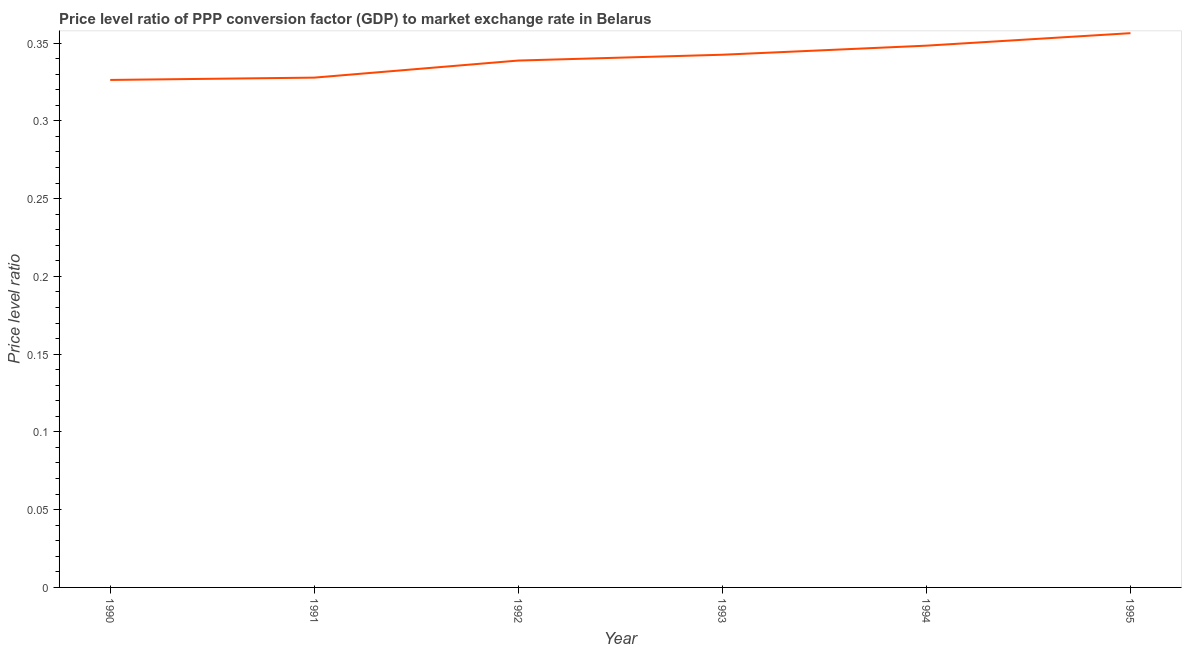What is the price level ratio in 1993?
Keep it short and to the point. 0.34. Across all years, what is the maximum price level ratio?
Your answer should be compact. 0.36. Across all years, what is the minimum price level ratio?
Your answer should be compact. 0.33. What is the sum of the price level ratio?
Give a very brief answer. 2.04. What is the difference between the price level ratio in 1992 and 1995?
Provide a short and direct response. -0.02. What is the average price level ratio per year?
Ensure brevity in your answer.  0.34. What is the median price level ratio?
Provide a short and direct response. 0.34. In how many years, is the price level ratio greater than 0.05 ?
Make the answer very short. 6. What is the ratio of the price level ratio in 1990 to that in 1992?
Provide a succinct answer. 0.96. What is the difference between the highest and the second highest price level ratio?
Keep it short and to the point. 0.01. What is the difference between the highest and the lowest price level ratio?
Offer a very short reply. 0.03. In how many years, is the price level ratio greater than the average price level ratio taken over all years?
Offer a very short reply. 3. Does the price level ratio monotonically increase over the years?
Give a very brief answer. Yes. What is the difference between two consecutive major ticks on the Y-axis?
Give a very brief answer. 0.05. What is the title of the graph?
Give a very brief answer. Price level ratio of PPP conversion factor (GDP) to market exchange rate in Belarus. What is the label or title of the X-axis?
Offer a terse response. Year. What is the label or title of the Y-axis?
Offer a terse response. Price level ratio. What is the Price level ratio in 1990?
Keep it short and to the point. 0.33. What is the Price level ratio of 1991?
Your answer should be very brief. 0.33. What is the Price level ratio of 1992?
Provide a short and direct response. 0.34. What is the Price level ratio of 1993?
Provide a succinct answer. 0.34. What is the Price level ratio of 1994?
Make the answer very short. 0.35. What is the Price level ratio of 1995?
Give a very brief answer. 0.36. What is the difference between the Price level ratio in 1990 and 1991?
Your answer should be very brief. -0. What is the difference between the Price level ratio in 1990 and 1992?
Provide a succinct answer. -0.01. What is the difference between the Price level ratio in 1990 and 1993?
Your answer should be very brief. -0.02. What is the difference between the Price level ratio in 1990 and 1994?
Ensure brevity in your answer.  -0.02. What is the difference between the Price level ratio in 1990 and 1995?
Offer a very short reply. -0.03. What is the difference between the Price level ratio in 1991 and 1992?
Your answer should be very brief. -0.01. What is the difference between the Price level ratio in 1991 and 1993?
Your answer should be very brief. -0.01. What is the difference between the Price level ratio in 1991 and 1994?
Give a very brief answer. -0.02. What is the difference between the Price level ratio in 1991 and 1995?
Your answer should be very brief. -0.03. What is the difference between the Price level ratio in 1992 and 1993?
Ensure brevity in your answer.  -0. What is the difference between the Price level ratio in 1992 and 1994?
Give a very brief answer. -0.01. What is the difference between the Price level ratio in 1992 and 1995?
Ensure brevity in your answer.  -0.02. What is the difference between the Price level ratio in 1993 and 1994?
Your answer should be compact. -0.01. What is the difference between the Price level ratio in 1993 and 1995?
Ensure brevity in your answer.  -0.01. What is the difference between the Price level ratio in 1994 and 1995?
Give a very brief answer. -0.01. What is the ratio of the Price level ratio in 1990 to that in 1993?
Provide a succinct answer. 0.95. What is the ratio of the Price level ratio in 1990 to that in 1994?
Provide a short and direct response. 0.94. What is the ratio of the Price level ratio in 1990 to that in 1995?
Keep it short and to the point. 0.92. What is the ratio of the Price level ratio in 1991 to that in 1993?
Give a very brief answer. 0.96. What is the ratio of the Price level ratio in 1991 to that in 1994?
Ensure brevity in your answer.  0.94. What is the ratio of the Price level ratio in 1991 to that in 1995?
Your answer should be compact. 0.92. What is the ratio of the Price level ratio in 1992 to that in 1994?
Provide a succinct answer. 0.97. What is the ratio of the Price level ratio in 1992 to that in 1995?
Keep it short and to the point. 0.95. What is the ratio of the Price level ratio in 1994 to that in 1995?
Provide a succinct answer. 0.98. 